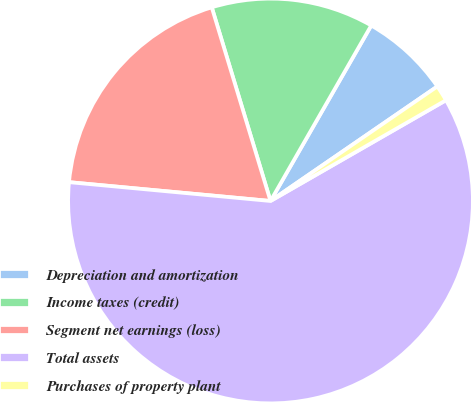<chart> <loc_0><loc_0><loc_500><loc_500><pie_chart><fcel>Depreciation and amortization<fcel>Income taxes (credit)<fcel>Segment net earnings (loss)<fcel>Total assets<fcel>Purchases of property plant<nl><fcel>7.13%<fcel>12.98%<fcel>18.83%<fcel>59.78%<fcel>1.28%<nl></chart> 